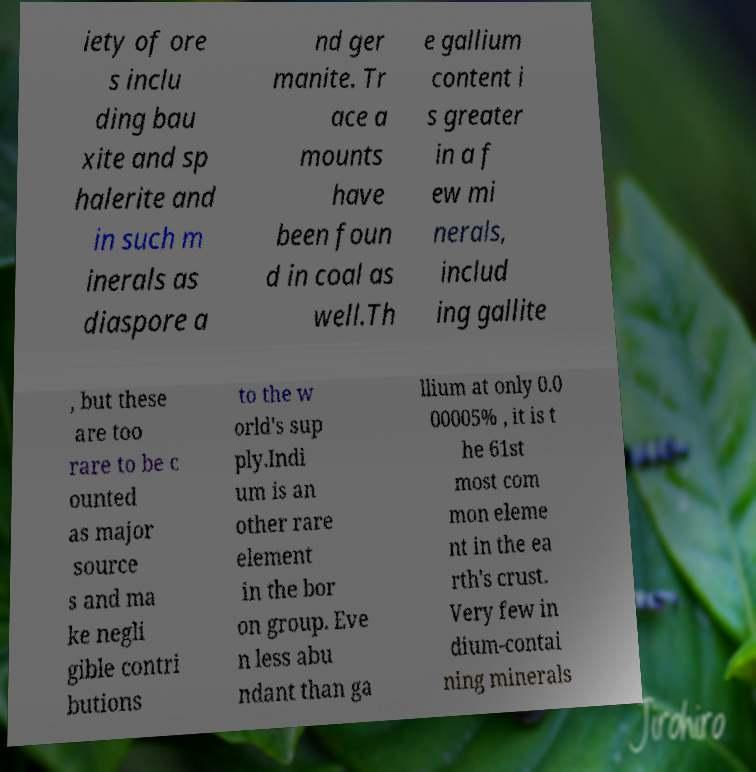There's text embedded in this image that I need extracted. Can you transcribe it verbatim? iety of ore s inclu ding bau xite and sp halerite and in such m inerals as diaspore a nd ger manite. Tr ace a mounts have been foun d in coal as well.Th e gallium content i s greater in a f ew mi nerals, includ ing gallite , but these are too rare to be c ounted as major source s and ma ke negli gible contri butions to the w orld's sup ply.Indi um is an other rare element in the bor on group. Eve n less abu ndant than ga llium at only 0.0 00005% , it is t he 61st most com mon eleme nt in the ea rth's crust. Very few in dium-contai ning minerals 